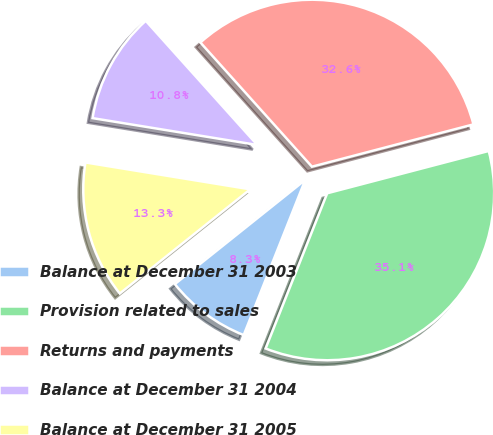<chart> <loc_0><loc_0><loc_500><loc_500><pie_chart><fcel>Balance at December 31 2003<fcel>Provision related to sales<fcel>Returns and payments<fcel>Balance at December 31 2004<fcel>Balance at December 31 2005<nl><fcel>8.26%<fcel>35.09%<fcel>32.57%<fcel>10.78%<fcel>13.3%<nl></chart> 